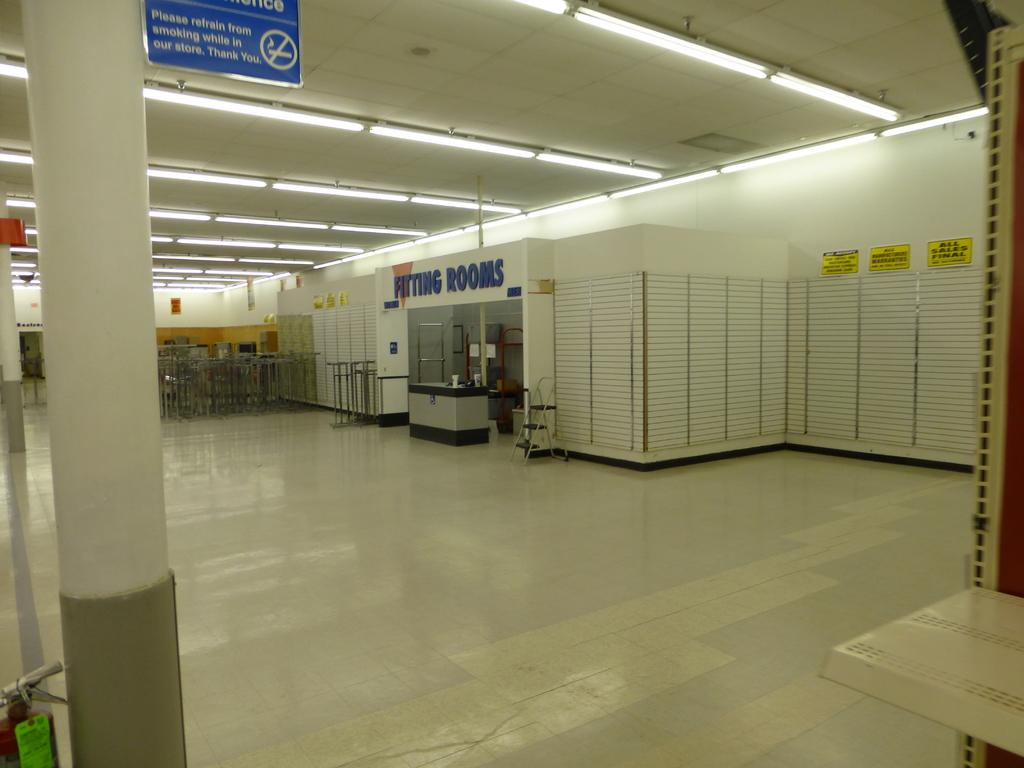What type of surface is visible at the bottom of the image? There is a floor in the image. What architectural feature can be seen in the image? There is a pillar in the image. What color is the board that is visible in the image? The board in the image is blue. What color is the wall that is visible in the image? The wall in the image is cream colored. What is located above the objects in the image? There is a ceiling in the image. What is attached to the ceiling in the image? There are lights attached to the ceiling in the image. Can you describe any other objects present in the image? There are other objects present in the image, but their specific details are not mentioned in the provided facts. What sense is being stimulated by the point of the action in the image? There is no specific action or sense being stimulated in the image, as it primarily features architectural elements and objects. 